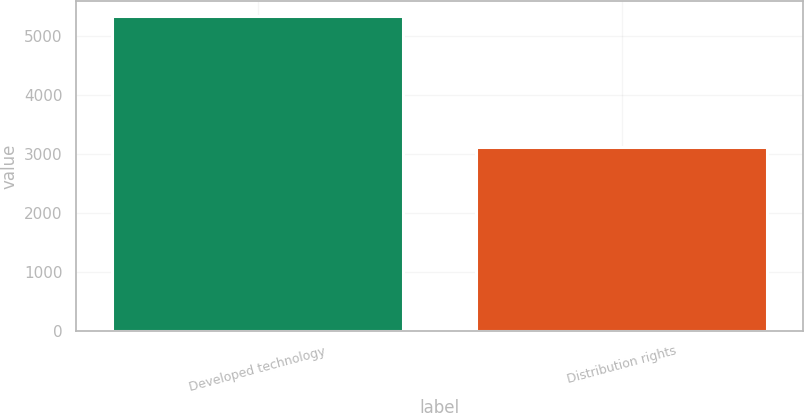<chart> <loc_0><loc_0><loc_500><loc_500><bar_chart><fcel>Developed technology<fcel>Distribution rights<nl><fcel>5329<fcel>3127<nl></chart> 